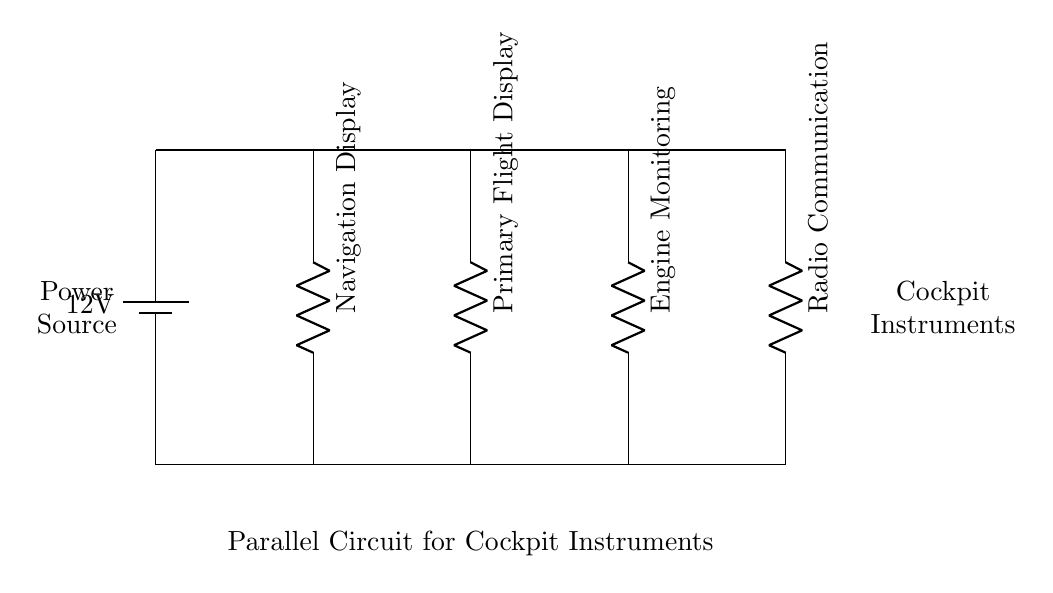What is the power source voltage? The power source in the circuit diagram is labeled as a battery with a voltage of 12V.
Answer: 12 volts Which cockpit instrument is located at the second position from the left? The second instrument from the left is the Primary Flight Display, as indicated by its placement in the parallel circuit layout.
Answer: Primary Flight Display How many instruments are connected in parallel? There are four instruments connected in parallel, which can be counted directly from the branches leading down from the main power distribution bus.
Answer: Four What type of circuit is represented in the diagram? The circuit is a parallel circuit, as evidenced by the multiple branches connected to the same power source, allowing independent operation of each instrument.
Answer: Parallel What is the purpose of the main power distribution bus? The main power distribution bus serves to distribute the 12V supply to all connected cockpit instruments, providing them with the necessary voltage for operation.
Answer: Distributes power If one instrument fails, what happens to the others? If one instrument fails, the others continue to function normally because they are connected in parallel, maintaining their individual paths to the power source.
Answer: Continue to function 